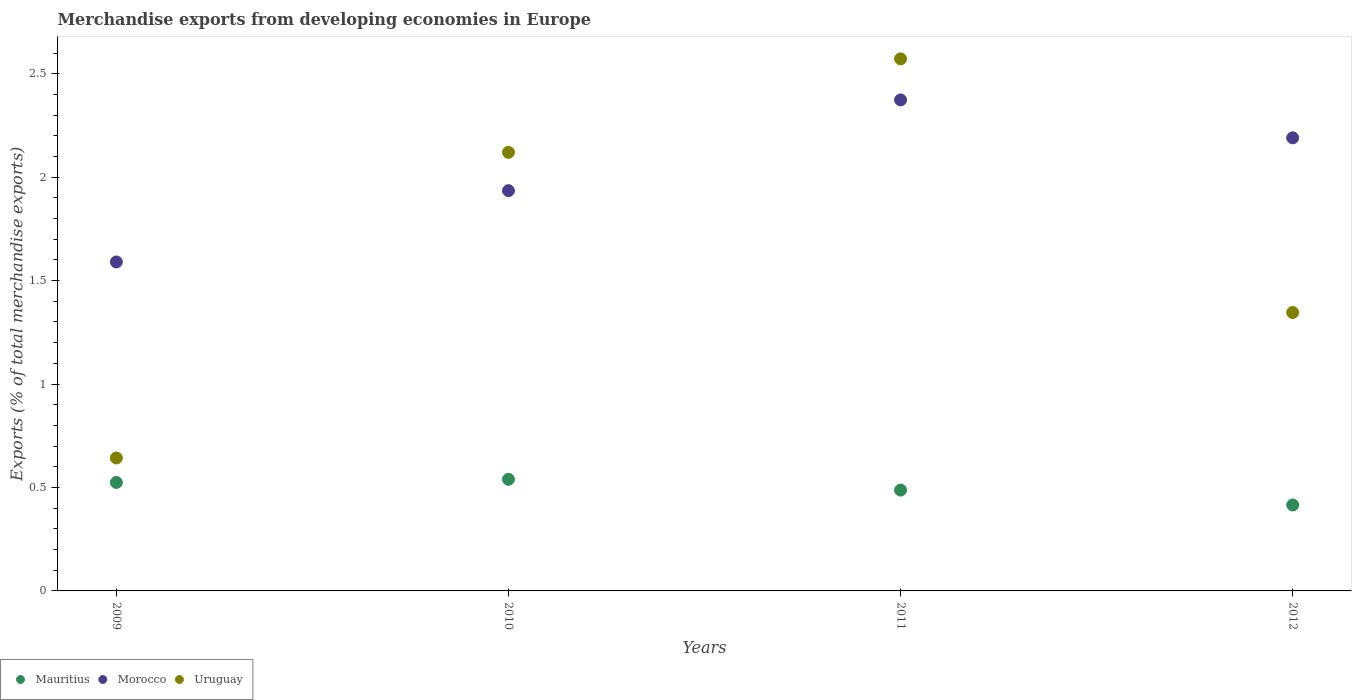How many different coloured dotlines are there?
Offer a very short reply. 3. What is the percentage of total merchandise exports in Mauritius in 2009?
Make the answer very short. 0.52. Across all years, what is the maximum percentage of total merchandise exports in Morocco?
Your response must be concise. 2.37. Across all years, what is the minimum percentage of total merchandise exports in Uruguay?
Give a very brief answer. 0.64. In which year was the percentage of total merchandise exports in Morocco maximum?
Offer a very short reply. 2011. In which year was the percentage of total merchandise exports in Morocco minimum?
Ensure brevity in your answer.  2009. What is the total percentage of total merchandise exports in Morocco in the graph?
Your response must be concise. 8.09. What is the difference between the percentage of total merchandise exports in Uruguay in 2009 and that in 2011?
Provide a short and direct response. -1.93. What is the difference between the percentage of total merchandise exports in Mauritius in 2011 and the percentage of total merchandise exports in Morocco in 2010?
Provide a short and direct response. -1.45. What is the average percentage of total merchandise exports in Uruguay per year?
Your answer should be compact. 1.67. In the year 2012, what is the difference between the percentage of total merchandise exports in Morocco and percentage of total merchandise exports in Mauritius?
Your response must be concise. 1.77. In how many years, is the percentage of total merchandise exports in Morocco greater than 1.5 %?
Your answer should be very brief. 4. What is the ratio of the percentage of total merchandise exports in Uruguay in 2009 to that in 2010?
Your response must be concise. 0.3. What is the difference between the highest and the second highest percentage of total merchandise exports in Uruguay?
Give a very brief answer. 0.45. What is the difference between the highest and the lowest percentage of total merchandise exports in Uruguay?
Make the answer very short. 1.93. In how many years, is the percentage of total merchandise exports in Uruguay greater than the average percentage of total merchandise exports in Uruguay taken over all years?
Your answer should be very brief. 2. Is the sum of the percentage of total merchandise exports in Morocco in 2010 and 2011 greater than the maximum percentage of total merchandise exports in Uruguay across all years?
Your answer should be compact. Yes. Is it the case that in every year, the sum of the percentage of total merchandise exports in Mauritius and percentage of total merchandise exports in Uruguay  is greater than the percentage of total merchandise exports in Morocco?
Provide a short and direct response. No. How many dotlines are there?
Provide a succinct answer. 3. What is the difference between two consecutive major ticks on the Y-axis?
Offer a very short reply. 0.5. Does the graph contain any zero values?
Provide a short and direct response. No. Does the graph contain grids?
Offer a very short reply. No. Where does the legend appear in the graph?
Give a very brief answer. Bottom left. How are the legend labels stacked?
Give a very brief answer. Horizontal. What is the title of the graph?
Give a very brief answer. Merchandise exports from developing economies in Europe. Does "French Polynesia" appear as one of the legend labels in the graph?
Keep it short and to the point. No. What is the label or title of the X-axis?
Provide a succinct answer. Years. What is the label or title of the Y-axis?
Your answer should be compact. Exports (% of total merchandise exports). What is the Exports (% of total merchandise exports) of Mauritius in 2009?
Your answer should be very brief. 0.52. What is the Exports (% of total merchandise exports) of Morocco in 2009?
Your answer should be compact. 1.59. What is the Exports (% of total merchandise exports) in Uruguay in 2009?
Your answer should be compact. 0.64. What is the Exports (% of total merchandise exports) of Mauritius in 2010?
Make the answer very short. 0.54. What is the Exports (% of total merchandise exports) of Morocco in 2010?
Keep it short and to the point. 1.93. What is the Exports (% of total merchandise exports) in Uruguay in 2010?
Offer a very short reply. 2.12. What is the Exports (% of total merchandise exports) of Mauritius in 2011?
Make the answer very short. 0.49. What is the Exports (% of total merchandise exports) in Morocco in 2011?
Keep it short and to the point. 2.37. What is the Exports (% of total merchandise exports) in Uruguay in 2011?
Provide a succinct answer. 2.57. What is the Exports (% of total merchandise exports) in Mauritius in 2012?
Give a very brief answer. 0.42. What is the Exports (% of total merchandise exports) of Morocco in 2012?
Your answer should be very brief. 2.19. What is the Exports (% of total merchandise exports) in Uruguay in 2012?
Your answer should be very brief. 1.35. Across all years, what is the maximum Exports (% of total merchandise exports) of Mauritius?
Your answer should be very brief. 0.54. Across all years, what is the maximum Exports (% of total merchandise exports) of Morocco?
Your answer should be compact. 2.37. Across all years, what is the maximum Exports (% of total merchandise exports) of Uruguay?
Make the answer very short. 2.57. Across all years, what is the minimum Exports (% of total merchandise exports) of Mauritius?
Offer a very short reply. 0.42. Across all years, what is the minimum Exports (% of total merchandise exports) in Morocco?
Your response must be concise. 1.59. Across all years, what is the minimum Exports (% of total merchandise exports) of Uruguay?
Your response must be concise. 0.64. What is the total Exports (% of total merchandise exports) in Mauritius in the graph?
Ensure brevity in your answer.  1.97. What is the total Exports (% of total merchandise exports) of Morocco in the graph?
Make the answer very short. 8.09. What is the total Exports (% of total merchandise exports) of Uruguay in the graph?
Your answer should be compact. 6.68. What is the difference between the Exports (% of total merchandise exports) of Mauritius in 2009 and that in 2010?
Provide a short and direct response. -0.02. What is the difference between the Exports (% of total merchandise exports) in Morocco in 2009 and that in 2010?
Ensure brevity in your answer.  -0.34. What is the difference between the Exports (% of total merchandise exports) in Uruguay in 2009 and that in 2010?
Your answer should be compact. -1.48. What is the difference between the Exports (% of total merchandise exports) of Mauritius in 2009 and that in 2011?
Ensure brevity in your answer.  0.04. What is the difference between the Exports (% of total merchandise exports) in Morocco in 2009 and that in 2011?
Make the answer very short. -0.78. What is the difference between the Exports (% of total merchandise exports) in Uruguay in 2009 and that in 2011?
Offer a very short reply. -1.93. What is the difference between the Exports (% of total merchandise exports) of Mauritius in 2009 and that in 2012?
Keep it short and to the point. 0.11. What is the difference between the Exports (% of total merchandise exports) of Morocco in 2009 and that in 2012?
Provide a succinct answer. -0.6. What is the difference between the Exports (% of total merchandise exports) of Uruguay in 2009 and that in 2012?
Your response must be concise. -0.7. What is the difference between the Exports (% of total merchandise exports) of Mauritius in 2010 and that in 2011?
Offer a terse response. 0.05. What is the difference between the Exports (% of total merchandise exports) of Morocco in 2010 and that in 2011?
Your answer should be very brief. -0.44. What is the difference between the Exports (% of total merchandise exports) in Uruguay in 2010 and that in 2011?
Provide a succinct answer. -0.45. What is the difference between the Exports (% of total merchandise exports) in Mauritius in 2010 and that in 2012?
Make the answer very short. 0.12. What is the difference between the Exports (% of total merchandise exports) of Morocco in 2010 and that in 2012?
Your response must be concise. -0.26. What is the difference between the Exports (% of total merchandise exports) in Uruguay in 2010 and that in 2012?
Your answer should be very brief. 0.77. What is the difference between the Exports (% of total merchandise exports) in Mauritius in 2011 and that in 2012?
Provide a short and direct response. 0.07. What is the difference between the Exports (% of total merchandise exports) of Morocco in 2011 and that in 2012?
Offer a very short reply. 0.18. What is the difference between the Exports (% of total merchandise exports) in Uruguay in 2011 and that in 2012?
Give a very brief answer. 1.23. What is the difference between the Exports (% of total merchandise exports) of Mauritius in 2009 and the Exports (% of total merchandise exports) of Morocco in 2010?
Make the answer very short. -1.41. What is the difference between the Exports (% of total merchandise exports) in Mauritius in 2009 and the Exports (% of total merchandise exports) in Uruguay in 2010?
Your answer should be compact. -1.6. What is the difference between the Exports (% of total merchandise exports) in Morocco in 2009 and the Exports (% of total merchandise exports) in Uruguay in 2010?
Provide a succinct answer. -0.53. What is the difference between the Exports (% of total merchandise exports) in Mauritius in 2009 and the Exports (% of total merchandise exports) in Morocco in 2011?
Provide a succinct answer. -1.85. What is the difference between the Exports (% of total merchandise exports) of Mauritius in 2009 and the Exports (% of total merchandise exports) of Uruguay in 2011?
Ensure brevity in your answer.  -2.05. What is the difference between the Exports (% of total merchandise exports) of Morocco in 2009 and the Exports (% of total merchandise exports) of Uruguay in 2011?
Your answer should be compact. -0.98. What is the difference between the Exports (% of total merchandise exports) in Mauritius in 2009 and the Exports (% of total merchandise exports) in Morocco in 2012?
Provide a succinct answer. -1.67. What is the difference between the Exports (% of total merchandise exports) of Mauritius in 2009 and the Exports (% of total merchandise exports) of Uruguay in 2012?
Make the answer very short. -0.82. What is the difference between the Exports (% of total merchandise exports) of Morocco in 2009 and the Exports (% of total merchandise exports) of Uruguay in 2012?
Offer a terse response. 0.24. What is the difference between the Exports (% of total merchandise exports) of Mauritius in 2010 and the Exports (% of total merchandise exports) of Morocco in 2011?
Offer a terse response. -1.83. What is the difference between the Exports (% of total merchandise exports) in Mauritius in 2010 and the Exports (% of total merchandise exports) in Uruguay in 2011?
Your answer should be compact. -2.03. What is the difference between the Exports (% of total merchandise exports) in Morocco in 2010 and the Exports (% of total merchandise exports) in Uruguay in 2011?
Offer a terse response. -0.64. What is the difference between the Exports (% of total merchandise exports) in Mauritius in 2010 and the Exports (% of total merchandise exports) in Morocco in 2012?
Keep it short and to the point. -1.65. What is the difference between the Exports (% of total merchandise exports) in Mauritius in 2010 and the Exports (% of total merchandise exports) in Uruguay in 2012?
Provide a succinct answer. -0.81. What is the difference between the Exports (% of total merchandise exports) in Morocco in 2010 and the Exports (% of total merchandise exports) in Uruguay in 2012?
Your answer should be very brief. 0.59. What is the difference between the Exports (% of total merchandise exports) in Mauritius in 2011 and the Exports (% of total merchandise exports) in Morocco in 2012?
Your answer should be compact. -1.7. What is the difference between the Exports (% of total merchandise exports) of Mauritius in 2011 and the Exports (% of total merchandise exports) of Uruguay in 2012?
Offer a very short reply. -0.86. What is the difference between the Exports (% of total merchandise exports) of Morocco in 2011 and the Exports (% of total merchandise exports) of Uruguay in 2012?
Keep it short and to the point. 1.03. What is the average Exports (% of total merchandise exports) of Mauritius per year?
Provide a short and direct response. 0.49. What is the average Exports (% of total merchandise exports) of Morocco per year?
Offer a terse response. 2.02. What is the average Exports (% of total merchandise exports) in Uruguay per year?
Your answer should be compact. 1.67. In the year 2009, what is the difference between the Exports (% of total merchandise exports) of Mauritius and Exports (% of total merchandise exports) of Morocco?
Offer a terse response. -1.07. In the year 2009, what is the difference between the Exports (% of total merchandise exports) of Mauritius and Exports (% of total merchandise exports) of Uruguay?
Provide a succinct answer. -0.12. In the year 2009, what is the difference between the Exports (% of total merchandise exports) of Morocco and Exports (% of total merchandise exports) of Uruguay?
Your answer should be very brief. 0.95. In the year 2010, what is the difference between the Exports (% of total merchandise exports) of Mauritius and Exports (% of total merchandise exports) of Morocco?
Your response must be concise. -1.4. In the year 2010, what is the difference between the Exports (% of total merchandise exports) of Mauritius and Exports (% of total merchandise exports) of Uruguay?
Give a very brief answer. -1.58. In the year 2010, what is the difference between the Exports (% of total merchandise exports) in Morocco and Exports (% of total merchandise exports) in Uruguay?
Offer a very short reply. -0.19. In the year 2011, what is the difference between the Exports (% of total merchandise exports) of Mauritius and Exports (% of total merchandise exports) of Morocco?
Your response must be concise. -1.89. In the year 2011, what is the difference between the Exports (% of total merchandise exports) of Mauritius and Exports (% of total merchandise exports) of Uruguay?
Provide a succinct answer. -2.08. In the year 2011, what is the difference between the Exports (% of total merchandise exports) of Morocco and Exports (% of total merchandise exports) of Uruguay?
Give a very brief answer. -0.2. In the year 2012, what is the difference between the Exports (% of total merchandise exports) in Mauritius and Exports (% of total merchandise exports) in Morocco?
Your answer should be compact. -1.77. In the year 2012, what is the difference between the Exports (% of total merchandise exports) in Mauritius and Exports (% of total merchandise exports) in Uruguay?
Your response must be concise. -0.93. In the year 2012, what is the difference between the Exports (% of total merchandise exports) of Morocco and Exports (% of total merchandise exports) of Uruguay?
Your answer should be very brief. 0.84. What is the ratio of the Exports (% of total merchandise exports) of Mauritius in 2009 to that in 2010?
Offer a terse response. 0.97. What is the ratio of the Exports (% of total merchandise exports) in Morocco in 2009 to that in 2010?
Your answer should be compact. 0.82. What is the ratio of the Exports (% of total merchandise exports) in Uruguay in 2009 to that in 2010?
Your answer should be very brief. 0.3. What is the ratio of the Exports (% of total merchandise exports) in Mauritius in 2009 to that in 2011?
Provide a short and direct response. 1.08. What is the ratio of the Exports (% of total merchandise exports) of Morocco in 2009 to that in 2011?
Your answer should be very brief. 0.67. What is the ratio of the Exports (% of total merchandise exports) in Uruguay in 2009 to that in 2011?
Your answer should be compact. 0.25. What is the ratio of the Exports (% of total merchandise exports) in Mauritius in 2009 to that in 2012?
Offer a terse response. 1.26. What is the ratio of the Exports (% of total merchandise exports) in Morocco in 2009 to that in 2012?
Offer a very short reply. 0.73. What is the ratio of the Exports (% of total merchandise exports) of Uruguay in 2009 to that in 2012?
Offer a very short reply. 0.48. What is the ratio of the Exports (% of total merchandise exports) of Mauritius in 2010 to that in 2011?
Your answer should be very brief. 1.11. What is the ratio of the Exports (% of total merchandise exports) in Morocco in 2010 to that in 2011?
Provide a succinct answer. 0.82. What is the ratio of the Exports (% of total merchandise exports) of Uruguay in 2010 to that in 2011?
Provide a short and direct response. 0.82. What is the ratio of the Exports (% of total merchandise exports) of Mauritius in 2010 to that in 2012?
Keep it short and to the point. 1.3. What is the ratio of the Exports (% of total merchandise exports) in Morocco in 2010 to that in 2012?
Provide a short and direct response. 0.88. What is the ratio of the Exports (% of total merchandise exports) in Uruguay in 2010 to that in 2012?
Provide a succinct answer. 1.58. What is the ratio of the Exports (% of total merchandise exports) in Mauritius in 2011 to that in 2012?
Offer a terse response. 1.17. What is the ratio of the Exports (% of total merchandise exports) in Morocco in 2011 to that in 2012?
Your response must be concise. 1.08. What is the ratio of the Exports (% of total merchandise exports) in Uruguay in 2011 to that in 2012?
Offer a very short reply. 1.91. What is the difference between the highest and the second highest Exports (% of total merchandise exports) in Mauritius?
Give a very brief answer. 0.02. What is the difference between the highest and the second highest Exports (% of total merchandise exports) of Morocco?
Your answer should be very brief. 0.18. What is the difference between the highest and the second highest Exports (% of total merchandise exports) in Uruguay?
Keep it short and to the point. 0.45. What is the difference between the highest and the lowest Exports (% of total merchandise exports) of Mauritius?
Provide a short and direct response. 0.12. What is the difference between the highest and the lowest Exports (% of total merchandise exports) in Morocco?
Your answer should be compact. 0.78. What is the difference between the highest and the lowest Exports (% of total merchandise exports) of Uruguay?
Give a very brief answer. 1.93. 